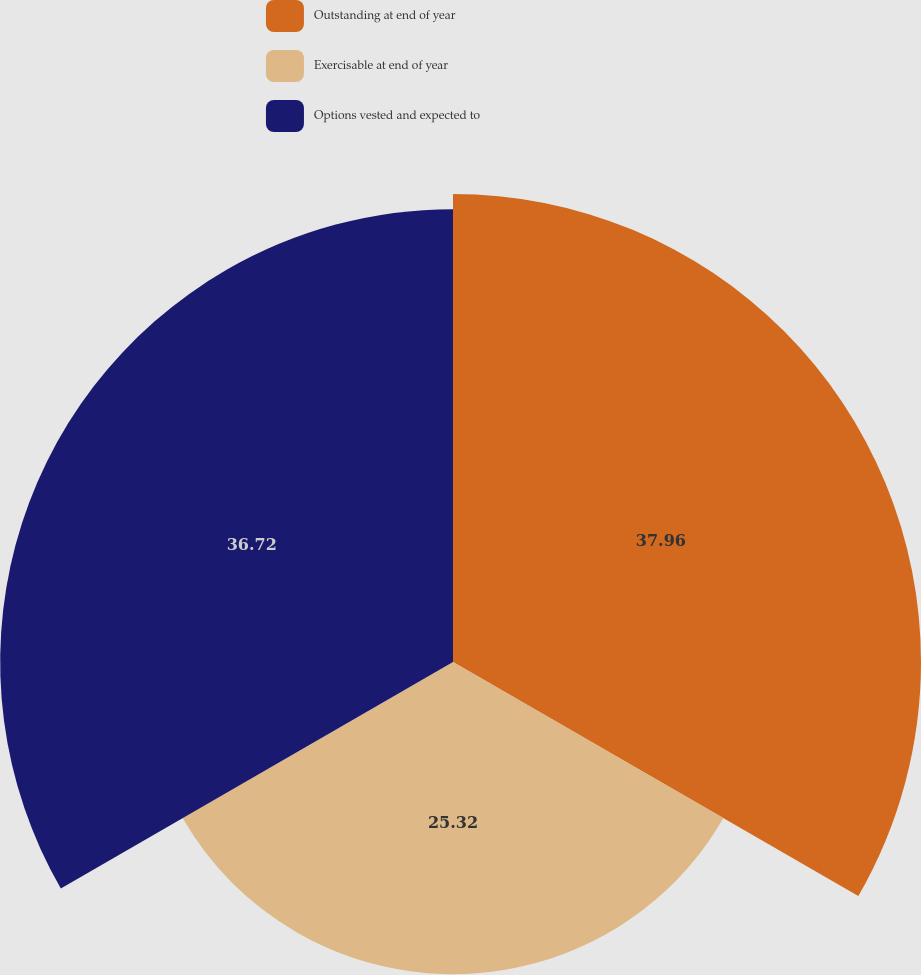Convert chart. <chart><loc_0><loc_0><loc_500><loc_500><pie_chart><fcel>Outstanding at end of year<fcel>Exercisable at end of year<fcel>Options vested and expected to<nl><fcel>37.95%<fcel>25.32%<fcel>36.72%<nl></chart> 